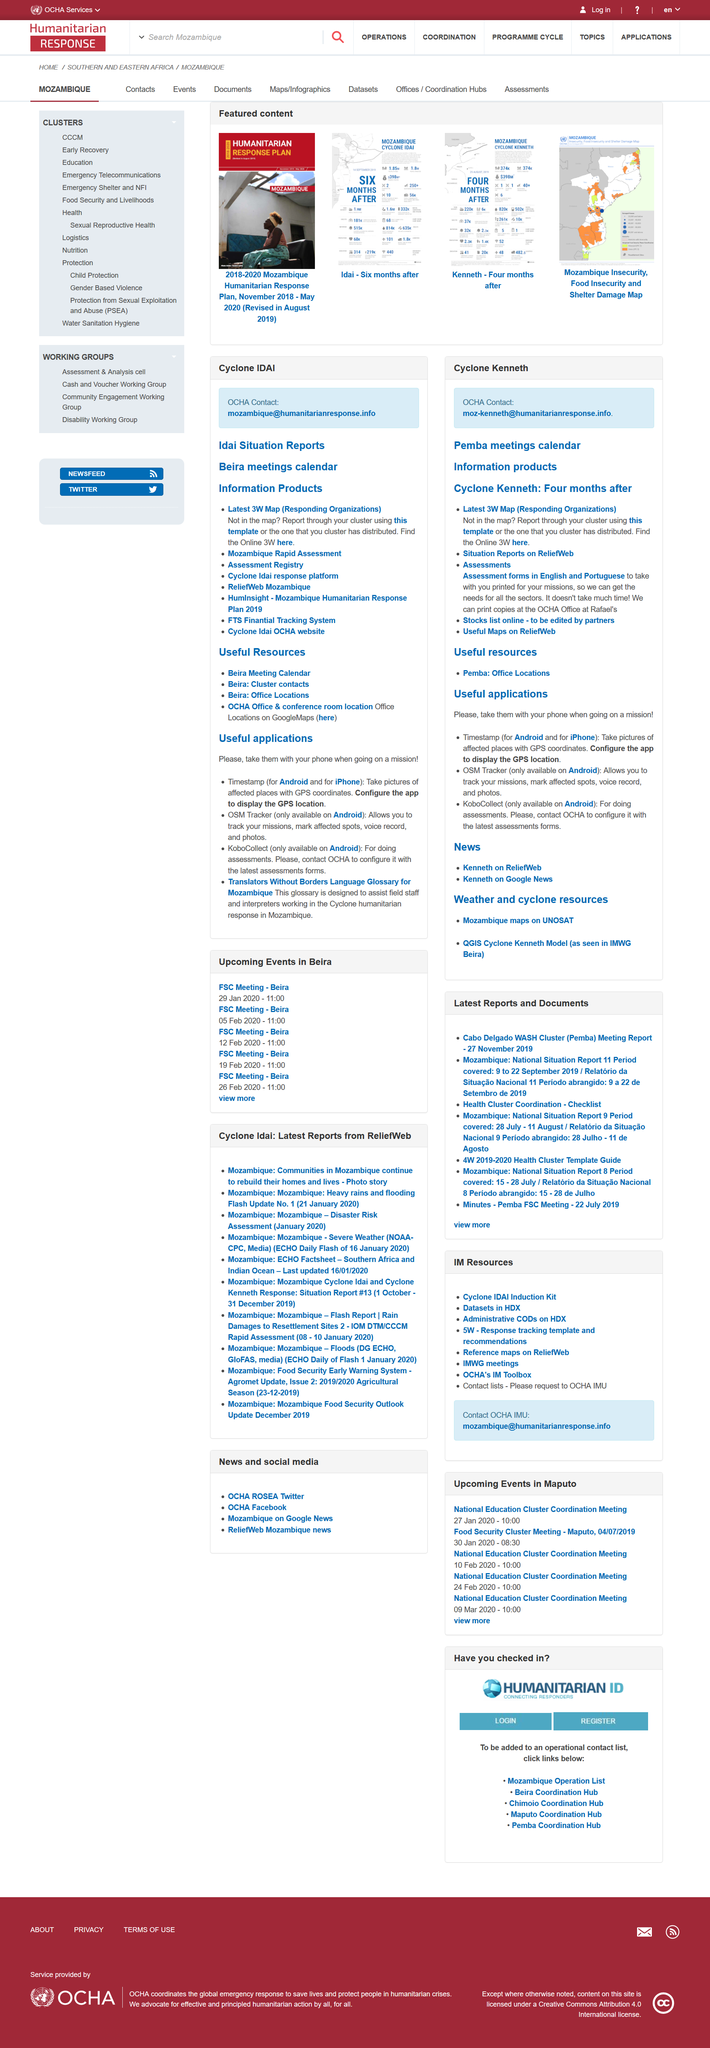Mention a couple of crucial points in this snapshot. A useful application that is available on the iPhone is the "Timestamp" application, which allows users to easily access the timestamp of their iPhone photos and videos. Yes, both Timestamp and KoboCollect are available on Android devices. OSM Tracker is a useful application that allows users to track their missions. 